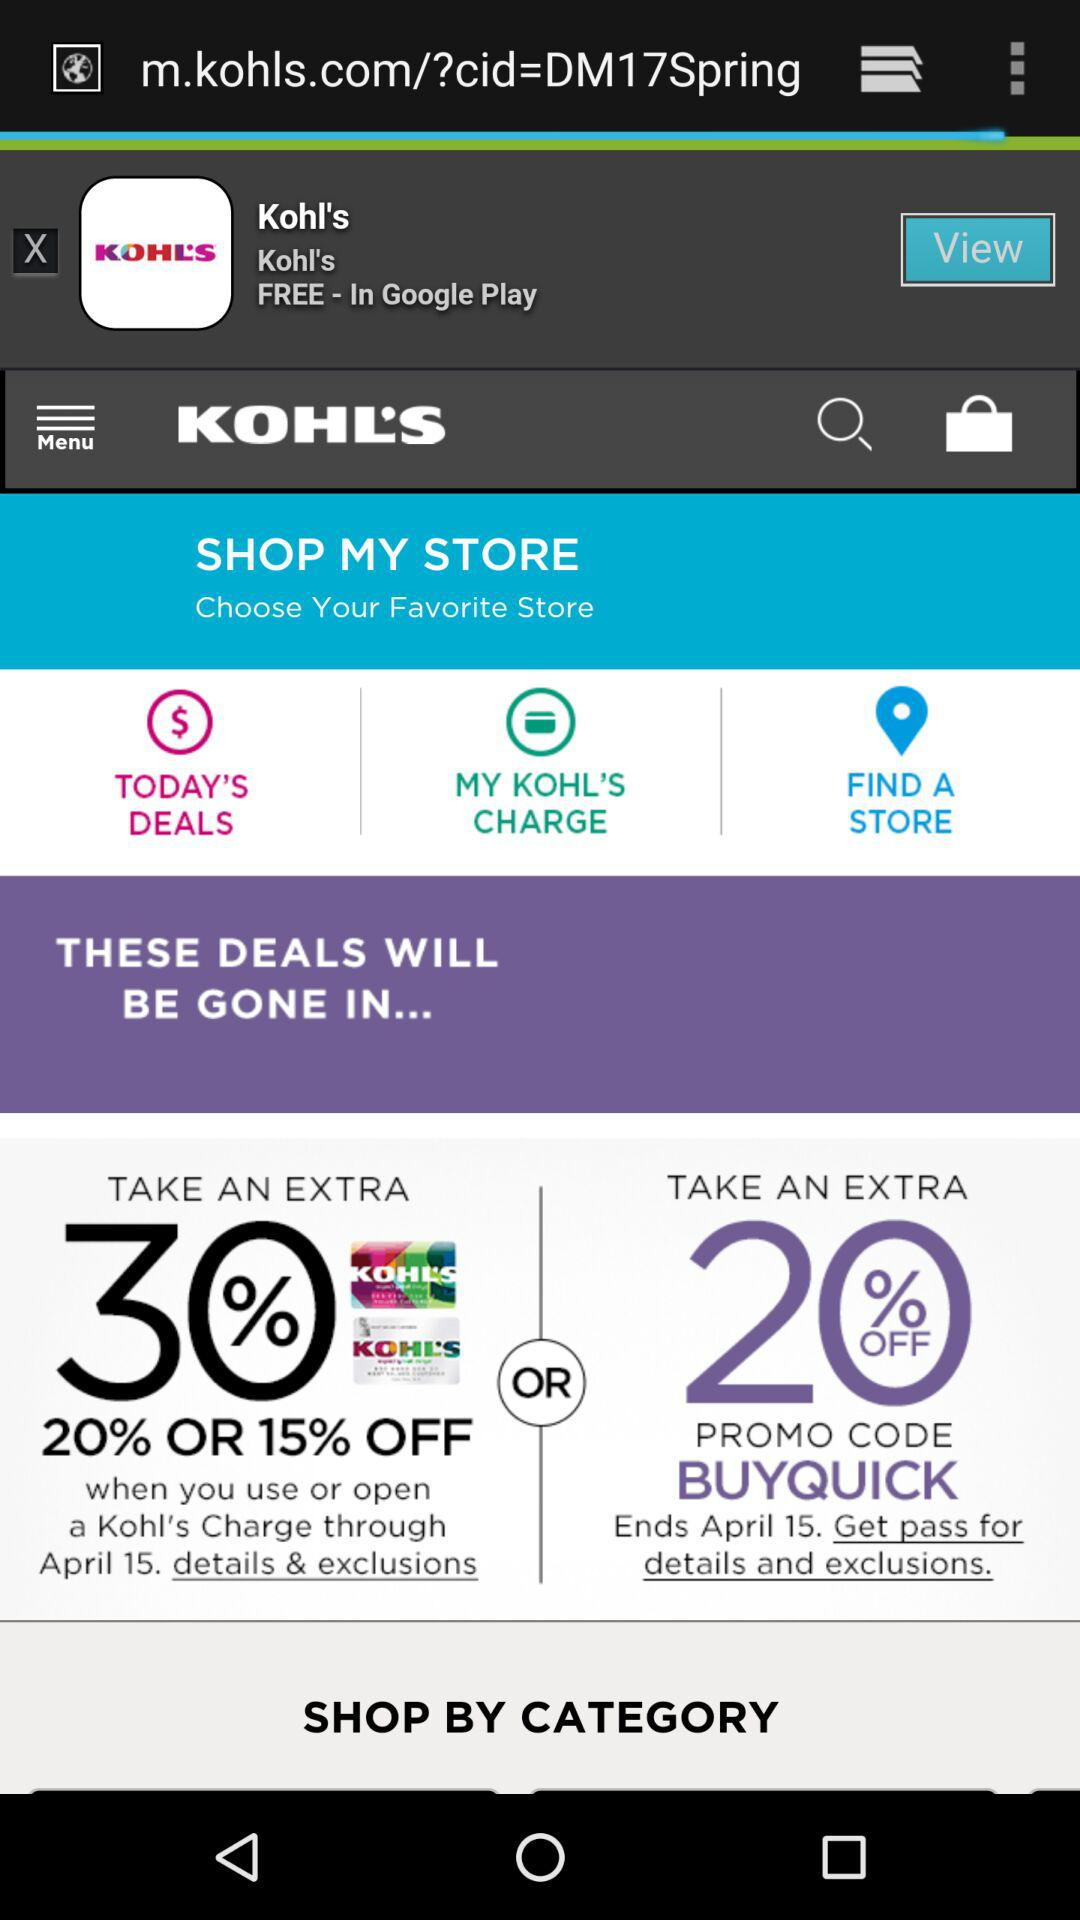What is the application name? The application name is "KOHL'S". 